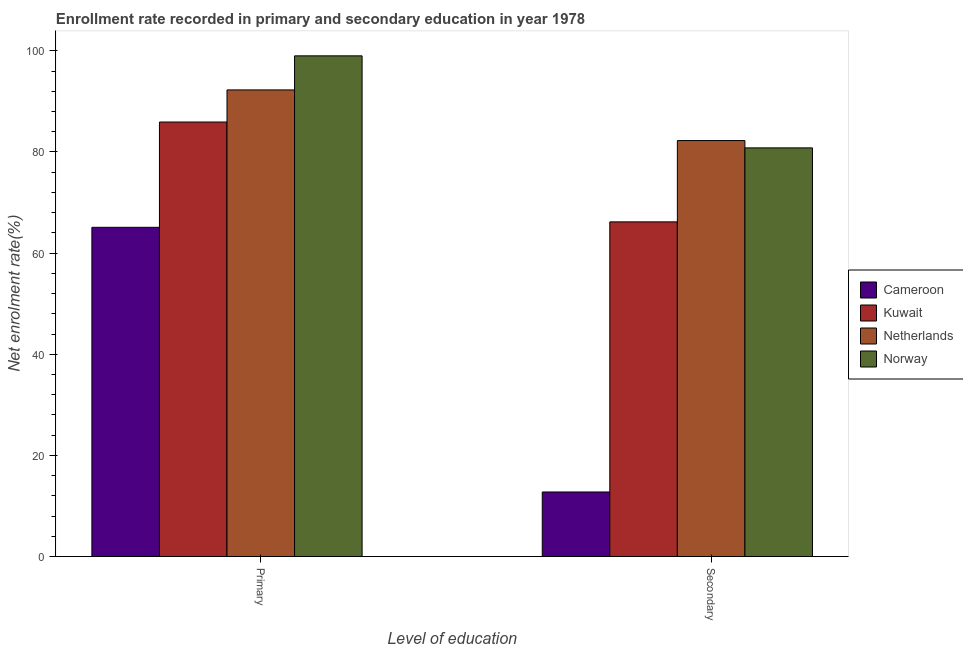How many groups of bars are there?
Your answer should be compact. 2. Are the number of bars on each tick of the X-axis equal?
Make the answer very short. Yes. What is the label of the 1st group of bars from the left?
Keep it short and to the point. Primary. What is the enrollment rate in primary education in Cameroon?
Provide a succinct answer. 65.09. Across all countries, what is the maximum enrollment rate in secondary education?
Your response must be concise. 82.25. Across all countries, what is the minimum enrollment rate in secondary education?
Provide a succinct answer. 12.76. In which country was the enrollment rate in secondary education minimum?
Offer a terse response. Cameroon. What is the total enrollment rate in secondary education in the graph?
Offer a terse response. 241.99. What is the difference between the enrollment rate in primary education in Cameroon and that in Norway?
Offer a terse response. -33.9. What is the difference between the enrollment rate in secondary education in Norway and the enrollment rate in primary education in Kuwait?
Provide a succinct answer. -5.11. What is the average enrollment rate in secondary education per country?
Offer a very short reply. 60.5. What is the difference between the enrollment rate in primary education and enrollment rate in secondary education in Netherlands?
Your response must be concise. 10.01. In how many countries, is the enrollment rate in secondary education greater than 64 %?
Offer a terse response. 3. What is the ratio of the enrollment rate in secondary education in Netherlands to that in Norway?
Offer a very short reply. 1.02. Is the enrollment rate in primary education in Cameroon less than that in Netherlands?
Your response must be concise. Yes. In how many countries, is the enrollment rate in secondary education greater than the average enrollment rate in secondary education taken over all countries?
Offer a very short reply. 3. What does the 2nd bar from the left in Secondary represents?
Your response must be concise. Kuwait. What does the 1st bar from the right in Primary represents?
Provide a short and direct response. Norway. How many bars are there?
Ensure brevity in your answer.  8. Are all the bars in the graph horizontal?
Give a very brief answer. No. How many countries are there in the graph?
Ensure brevity in your answer.  4. What is the difference between two consecutive major ticks on the Y-axis?
Make the answer very short. 20. Are the values on the major ticks of Y-axis written in scientific E-notation?
Provide a short and direct response. No. Does the graph contain grids?
Make the answer very short. No. How many legend labels are there?
Make the answer very short. 4. What is the title of the graph?
Keep it short and to the point. Enrollment rate recorded in primary and secondary education in year 1978. Does "Mauritius" appear as one of the legend labels in the graph?
Your answer should be compact. No. What is the label or title of the X-axis?
Provide a short and direct response. Level of education. What is the label or title of the Y-axis?
Make the answer very short. Net enrolment rate(%). What is the Net enrolment rate(%) in Cameroon in Primary?
Your answer should be compact. 65.09. What is the Net enrolment rate(%) in Kuwait in Primary?
Your answer should be compact. 85.91. What is the Net enrolment rate(%) in Netherlands in Primary?
Ensure brevity in your answer.  92.26. What is the Net enrolment rate(%) in Norway in Primary?
Your answer should be very brief. 99. What is the Net enrolment rate(%) of Cameroon in Secondary?
Offer a very short reply. 12.76. What is the Net enrolment rate(%) of Kuwait in Secondary?
Provide a short and direct response. 66.17. What is the Net enrolment rate(%) of Netherlands in Secondary?
Your response must be concise. 82.25. What is the Net enrolment rate(%) in Norway in Secondary?
Offer a very short reply. 80.8. Across all Level of education, what is the maximum Net enrolment rate(%) of Cameroon?
Provide a succinct answer. 65.09. Across all Level of education, what is the maximum Net enrolment rate(%) in Kuwait?
Your answer should be compact. 85.91. Across all Level of education, what is the maximum Net enrolment rate(%) of Netherlands?
Your answer should be very brief. 92.26. Across all Level of education, what is the maximum Net enrolment rate(%) in Norway?
Your answer should be compact. 99. Across all Level of education, what is the minimum Net enrolment rate(%) of Cameroon?
Offer a terse response. 12.76. Across all Level of education, what is the minimum Net enrolment rate(%) of Kuwait?
Give a very brief answer. 66.17. Across all Level of education, what is the minimum Net enrolment rate(%) in Netherlands?
Offer a very short reply. 82.25. Across all Level of education, what is the minimum Net enrolment rate(%) of Norway?
Your response must be concise. 80.8. What is the total Net enrolment rate(%) in Cameroon in the graph?
Offer a terse response. 77.85. What is the total Net enrolment rate(%) of Kuwait in the graph?
Keep it short and to the point. 152.09. What is the total Net enrolment rate(%) in Netherlands in the graph?
Ensure brevity in your answer.  174.51. What is the total Net enrolment rate(%) in Norway in the graph?
Provide a succinct answer. 179.8. What is the difference between the Net enrolment rate(%) of Cameroon in Primary and that in Secondary?
Keep it short and to the point. 52.33. What is the difference between the Net enrolment rate(%) in Kuwait in Primary and that in Secondary?
Your answer should be compact. 19.74. What is the difference between the Net enrolment rate(%) of Netherlands in Primary and that in Secondary?
Provide a succinct answer. 10.01. What is the difference between the Net enrolment rate(%) in Norway in Primary and that in Secondary?
Your answer should be very brief. 18.2. What is the difference between the Net enrolment rate(%) in Cameroon in Primary and the Net enrolment rate(%) in Kuwait in Secondary?
Provide a short and direct response. -1.08. What is the difference between the Net enrolment rate(%) of Cameroon in Primary and the Net enrolment rate(%) of Netherlands in Secondary?
Your answer should be very brief. -17.16. What is the difference between the Net enrolment rate(%) in Cameroon in Primary and the Net enrolment rate(%) in Norway in Secondary?
Keep it short and to the point. -15.71. What is the difference between the Net enrolment rate(%) in Kuwait in Primary and the Net enrolment rate(%) in Netherlands in Secondary?
Ensure brevity in your answer.  3.67. What is the difference between the Net enrolment rate(%) of Kuwait in Primary and the Net enrolment rate(%) of Norway in Secondary?
Make the answer very short. 5.11. What is the difference between the Net enrolment rate(%) in Netherlands in Primary and the Net enrolment rate(%) in Norway in Secondary?
Keep it short and to the point. 11.46. What is the average Net enrolment rate(%) of Cameroon per Level of education?
Provide a short and direct response. 38.93. What is the average Net enrolment rate(%) in Kuwait per Level of education?
Make the answer very short. 76.04. What is the average Net enrolment rate(%) in Netherlands per Level of education?
Keep it short and to the point. 87.26. What is the average Net enrolment rate(%) of Norway per Level of education?
Provide a short and direct response. 89.9. What is the difference between the Net enrolment rate(%) of Cameroon and Net enrolment rate(%) of Kuwait in Primary?
Ensure brevity in your answer.  -20.82. What is the difference between the Net enrolment rate(%) in Cameroon and Net enrolment rate(%) in Netherlands in Primary?
Ensure brevity in your answer.  -27.17. What is the difference between the Net enrolment rate(%) of Cameroon and Net enrolment rate(%) of Norway in Primary?
Your response must be concise. -33.91. What is the difference between the Net enrolment rate(%) in Kuwait and Net enrolment rate(%) in Netherlands in Primary?
Give a very brief answer. -6.35. What is the difference between the Net enrolment rate(%) in Kuwait and Net enrolment rate(%) in Norway in Primary?
Provide a short and direct response. -13.08. What is the difference between the Net enrolment rate(%) of Netherlands and Net enrolment rate(%) of Norway in Primary?
Offer a terse response. -6.73. What is the difference between the Net enrolment rate(%) in Cameroon and Net enrolment rate(%) in Kuwait in Secondary?
Provide a succinct answer. -53.41. What is the difference between the Net enrolment rate(%) in Cameroon and Net enrolment rate(%) in Netherlands in Secondary?
Provide a short and direct response. -69.49. What is the difference between the Net enrolment rate(%) in Cameroon and Net enrolment rate(%) in Norway in Secondary?
Ensure brevity in your answer.  -68.04. What is the difference between the Net enrolment rate(%) in Kuwait and Net enrolment rate(%) in Netherlands in Secondary?
Offer a terse response. -16.08. What is the difference between the Net enrolment rate(%) of Kuwait and Net enrolment rate(%) of Norway in Secondary?
Give a very brief answer. -14.63. What is the difference between the Net enrolment rate(%) of Netherlands and Net enrolment rate(%) of Norway in Secondary?
Provide a succinct answer. 1.45. What is the ratio of the Net enrolment rate(%) in Cameroon in Primary to that in Secondary?
Keep it short and to the point. 5.1. What is the ratio of the Net enrolment rate(%) of Kuwait in Primary to that in Secondary?
Your response must be concise. 1.3. What is the ratio of the Net enrolment rate(%) in Netherlands in Primary to that in Secondary?
Keep it short and to the point. 1.12. What is the ratio of the Net enrolment rate(%) in Norway in Primary to that in Secondary?
Your answer should be very brief. 1.23. What is the difference between the highest and the second highest Net enrolment rate(%) of Cameroon?
Offer a very short reply. 52.33. What is the difference between the highest and the second highest Net enrolment rate(%) in Kuwait?
Provide a succinct answer. 19.74. What is the difference between the highest and the second highest Net enrolment rate(%) of Netherlands?
Ensure brevity in your answer.  10.01. What is the difference between the highest and the second highest Net enrolment rate(%) of Norway?
Your response must be concise. 18.2. What is the difference between the highest and the lowest Net enrolment rate(%) of Cameroon?
Provide a short and direct response. 52.33. What is the difference between the highest and the lowest Net enrolment rate(%) of Kuwait?
Give a very brief answer. 19.74. What is the difference between the highest and the lowest Net enrolment rate(%) of Netherlands?
Your answer should be very brief. 10.01. What is the difference between the highest and the lowest Net enrolment rate(%) in Norway?
Make the answer very short. 18.2. 